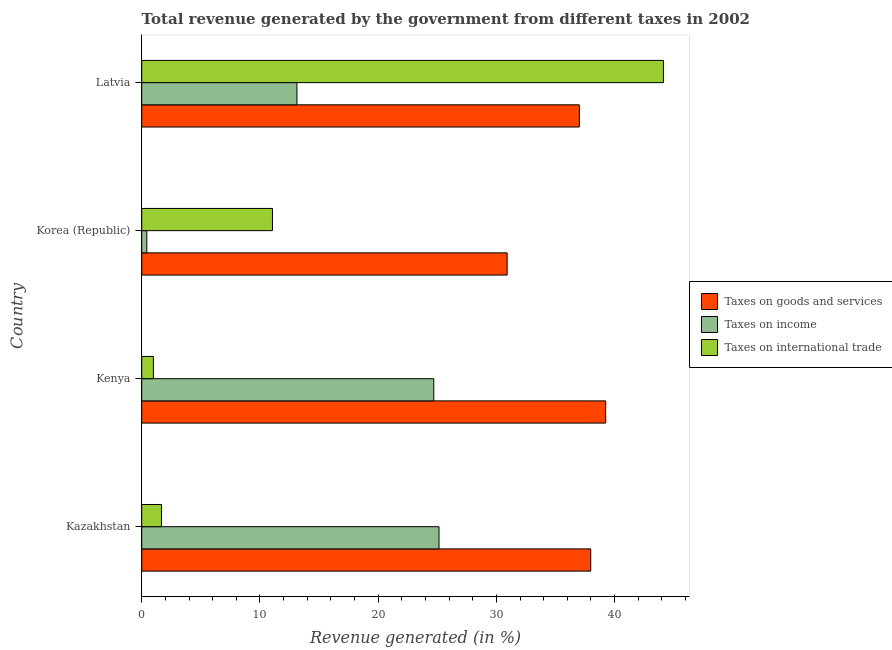How many different coloured bars are there?
Your response must be concise. 3. How many groups of bars are there?
Offer a terse response. 4. Are the number of bars on each tick of the Y-axis equal?
Your response must be concise. Yes. What is the label of the 3rd group of bars from the top?
Provide a short and direct response. Kenya. In how many cases, is the number of bars for a given country not equal to the number of legend labels?
Your answer should be very brief. 0. What is the percentage of revenue generated by taxes on goods and services in Kazakhstan?
Keep it short and to the point. 37.98. Across all countries, what is the maximum percentage of revenue generated by taxes on goods and services?
Your response must be concise. 39.24. Across all countries, what is the minimum percentage of revenue generated by taxes on income?
Provide a succinct answer. 0.43. In which country was the percentage of revenue generated by tax on international trade maximum?
Your response must be concise. Latvia. In which country was the percentage of revenue generated by taxes on income minimum?
Ensure brevity in your answer.  Korea (Republic). What is the total percentage of revenue generated by taxes on income in the graph?
Your answer should be compact. 63.41. What is the difference between the percentage of revenue generated by tax on international trade in Korea (Republic) and that in Latvia?
Your response must be concise. -33.07. What is the difference between the percentage of revenue generated by tax on international trade in Latvia and the percentage of revenue generated by taxes on goods and services in Kenya?
Give a very brief answer. 4.89. What is the average percentage of revenue generated by taxes on goods and services per country?
Provide a short and direct response. 36.29. What is the difference between the percentage of revenue generated by taxes on goods and services and percentage of revenue generated by tax on international trade in Kenya?
Ensure brevity in your answer.  38.26. What is the ratio of the percentage of revenue generated by taxes on income in Kazakhstan to that in Korea (Republic)?
Keep it short and to the point. 58.42. What is the difference between the highest and the second highest percentage of revenue generated by taxes on income?
Give a very brief answer. 0.44. What is the difference between the highest and the lowest percentage of revenue generated by taxes on goods and services?
Make the answer very short. 8.33. Is the sum of the percentage of revenue generated by taxes on income in Kazakhstan and Korea (Republic) greater than the maximum percentage of revenue generated by taxes on goods and services across all countries?
Provide a short and direct response. No. What does the 2nd bar from the top in Latvia represents?
Your answer should be very brief. Taxes on income. What does the 2nd bar from the bottom in Kenya represents?
Your response must be concise. Taxes on income. How many bars are there?
Your answer should be very brief. 12. Are all the bars in the graph horizontal?
Provide a succinct answer. Yes. What is the difference between two consecutive major ticks on the X-axis?
Give a very brief answer. 10. Does the graph contain any zero values?
Keep it short and to the point. No. Where does the legend appear in the graph?
Offer a terse response. Center right. How many legend labels are there?
Your answer should be compact. 3. What is the title of the graph?
Offer a very short reply. Total revenue generated by the government from different taxes in 2002. What is the label or title of the X-axis?
Your response must be concise. Revenue generated (in %). What is the Revenue generated (in %) in Taxes on goods and services in Kazakhstan?
Make the answer very short. 37.98. What is the Revenue generated (in %) of Taxes on income in Kazakhstan?
Your answer should be compact. 25.15. What is the Revenue generated (in %) of Taxes on international trade in Kazakhstan?
Make the answer very short. 1.67. What is the Revenue generated (in %) in Taxes on goods and services in Kenya?
Offer a terse response. 39.24. What is the Revenue generated (in %) of Taxes on income in Kenya?
Your response must be concise. 24.71. What is the Revenue generated (in %) in Taxes on international trade in Kenya?
Offer a very short reply. 0.99. What is the Revenue generated (in %) in Taxes on goods and services in Korea (Republic)?
Make the answer very short. 30.91. What is the Revenue generated (in %) in Taxes on income in Korea (Republic)?
Make the answer very short. 0.43. What is the Revenue generated (in %) in Taxes on international trade in Korea (Republic)?
Offer a very short reply. 11.06. What is the Revenue generated (in %) in Taxes on goods and services in Latvia?
Ensure brevity in your answer.  37.02. What is the Revenue generated (in %) in Taxes on income in Latvia?
Offer a very short reply. 13.13. What is the Revenue generated (in %) of Taxes on international trade in Latvia?
Provide a short and direct response. 44.13. Across all countries, what is the maximum Revenue generated (in %) of Taxes on goods and services?
Ensure brevity in your answer.  39.24. Across all countries, what is the maximum Revenue generated (in %) of Taxes on income?
Provide a short and direct response. 25.15. Across all countries, what is the maximum Revenue generated (in %) of Taxes on international trade?
Offer a terse response. 44.13. Across all countries, what is the minimum Revenue generated (in %) in Taxes on goods and services?
Provide a short and direct response. 30.91. Across all countries, what is the minimum Revenue generated (in %) in Taxes on income?
Give a very brief answer. 0.43. Across all countries, what is the minimum Revenue generated (in %) of Taxes on international trade?
Your answer should be very brief. 0.99. What is the total Revenue generated (in %) of Taxes on goods and services in the graph?
Offer a very short reply. 145.15. What is the total Revenue generated (in %) of Taxes on income in the graph?
Keep it short and to the point. 63.41. What is the total Revenue generated (in %) of Taxes on international trade in the graph?
Your answer should be very brief. 57.85. What is the difference between the Revenue generated (in %) of Taxes on goods and services in Kazakhstan and that in Kenya?
Make the answer very short. -1.26. What is the difference between the Revenue generated (in %) of Taxes on income in Kazakhstan and that in Kenya?
Your answer should be very brief. 0.44. What is the difference between the Revenue generated (in %) in Taxes on international trade in Kazakhstan and that in Kenya?
Offer a terse response. 0.69. What is the difference between the Revenue generated (in %) in Taxes on goods and services in Kazakhstan and that in Korea (Republic)?
Give a very brief answer. 7.07. What is the difference between the Revenue generated (in %) in Taxes on income in Kazakhstan and that in Korea (Republic)?
Offer a terse response. 24.72. What is the difference between the Revenue generated (in %) of Taxes on international trade in Kazakhstan and that in Korea (Republic)?
Give a very brief answer. -9.39. What is the difference between the Revenue generated (in %) in Taxes on goods and services in Kazakhstan and that in Latvia?
Your answer should be very brief. 0.96. What is the difference between the Revenue generated (in %) in Taxes on income in Kazakhstan and that in Latvia?
Your answer should be compact. 12.02. What is the difference between the Revenue generated (in %) in Taxes on international trade in Kazakhstan and that in Latvia?
Ensure brevity in your answer.  -42.46. What is the difference between the Revenue generated (in %) in Taxes on goods and services in Kenya and that in Korea (Republic)?
Ensure brevity in your answer.  8.33. What is the difference between the Revenue generated (in %) of Taxes on income in Kenya and that in Korea (Republic)?
Your answer should be compact. 24.28. What is the difference between the Revenue generated (in %) of Taxes on international trade in Kenya and that in Korea (Republic)?
Make the answer very short. -10.07. What is the difference between the Revenue generated (in %) of Taxes on goods and services in Kenya and that in Latvia?
Offer a very short reply. 2.23. What is the difference between the Revenue generated (in %) of Taxes on income in Kenya and that in Latvia?
Your answer should be very brief. 11.58. What is the difference between the Revenue generated (in %) of Taxes on international trade in Kenya and that in Latvia?
Ensure brevity in your answer.  -43.14. What is the difference between the Revenue generated (in %) in Taxes on goods and services in Korea (Republic) and that in Latvia?
Your answer should be very brief. -6.11. What is the difference between the Revenue generated (in %) in Taxes on income in Korea (Republic) and that in Latvia?
Ensure brevity in your answer.  -12.7. What is the difference between the Revenue generated (in %) of Taxes on international trade in Korea (Republic) and that in Latvia?
Your response must be concise. -33.07. What is the difference between the Revenue generated (in %) of Taxes on goods and services in Kazakhstan and the Revenue generated (in %) of Taxes on income in Kenya?
Your answer should be compact. 13.28. What is the difference between the Revenue generated (in %) of Taxes on goods and services in Kazakhstan and the Revenue generated (in %) of Taxes on international trade in Kenya?
Your answer should be very brief. 36.99. What is the difference between the Revenue generated (in %) of Taxes on income in Kazakhstan and the Revenue generated (in %) of Taxes on international trade in Kenya?
Your answer should be very brief. 24.16. What is the difference between the Revenue generated (in %) in Taxes on goods and services in Kazakhstan and the Revenue generated (in %) in Taxes on income in Korea (Republic)?
Offer a terse response. 37.55. What is the difference between the Revenue generated (in %) in Taxes on goods and services in Kazakhstan and the Revenue generated (in %) in Taxes on international trade in Korea (Republic)?
Ensure brevity in your answer.  26.92. What is the difference between the Revenue generated (in %) of Taxes on income in Kazakhstan and the Revenue generated (in %) of Taxes on international trade in Korea (Republic)?
Provide a short and direct response. 14.09. What is the difference between the Revenue generated (in %) in Taxes on goods and services in Kazakhstan and the Revenue generated (in %) in Taxes on income in Latvia?
Your answer should be very brief. 24.85. What is the difference between the Revenue generated (in %) in Taxes on goods and services in Kazakhstan and the Revenue generated (in %) in Taxes on international trade in Latvia?
Your answer should be compact. -6.15. What is the difference between the Revenue generated (in %) in Taxes on income in Kazakhstan and the Revenue generated (in %) in Taxes on international trade in Latvia?
Offer a very short reply. -18.98. What is the difference between the Revenue generated (in %) in Taxes on goods and services in Kenya and the Revenue generated (in %) in Taxes on income in Korea (Republic)?
Give a very brief answer. 38.81. What is the difference between the Revenue generated (in %) of Taxes on goods and services in Kenya and the Revenue generated (in %) of Taxes on international trade in Korea (Republic)?
Your answer should be compact. 28.18. What is the difference between the Revenue generated (in %) in Taxes on income in Kenya and the Revenue generated (in %) in Taxes on international trade in Korea (Republic)?
Your answer should be very brief. 13.65. What is the difference between the Revenue generated (in %) in Taxes on goods and services in Kenya and the Revenue generated (in %) in Taxes on income in Latvia?
Provide a short and direct response. 26.11. What is the difference between the Revenue generated (in %) in Taxes on goods and services in Kenya and the Revenue generated (in %) in Taxes on international trade in Latvia?
Your response must be concise. -4.89. What is the difference between the Revenue generated (in %) of Taxes on income in Kenya and the Revenue generated (in %) of Taxes on international trade in Latvia?
Your answer should be very brief. -19.43. What is the difference between the Revenue generated (in %) in Taxes on goods and services in Korea (Republic) and the Revenue generated (in %) in Taxes on income in Latvia?
Your answer should be very brief. 17.78. What is the difference between the Revenue generated (in %) in Taxes on goods and services in Korea (Republic) and the Revenue generated (in %) in Taxes on international trade in Latvia?
Provide a short and direct response. -13.22. What is the difference between the Revenue generated (in %) in Taxes on income in Korea (Republic) and the Revenue generated (in %) in Taxes on international trade in Latvia?
Provide a short and direct response. -43.7. What is the average Revenue generated (in %) in Taxes on goods and services per country?
Your response must be concise. 36.29. What is the average Revenue generated (in %) of Taxes on income per country?
Your answer should be compact. 15.85. What is the average Revenue generated (in %) of Taxes on international trade per country?
Your response must be concise. 14.46. What is the difference between the Revenue generated (in %) in Taxes on goods and services and Revenue generated (in %) in Taxes on income in Kazakhstan?
Provide a succinct answer. 12.83. What is the difference between the Revenue generated (in %) in Taxes on goods and services and Revenue generated (in %) in Taxes on international trade in Kazakhstan?
Ensure brevity in your answer.  36.31. What is the difference between the Revenue generated (in %) in Taxes on income and Revenue generated (in %) in Taxes on international trade in Kazakhstan?
Give a very brief answer. 23.48. What is the difference between the Revenue generated (in %) of Taxes on goods and services and Revenue generated (in %) of Taxes on income in Kenya?
Provide a succinct answer. 14.54. What is the difference between the Revenue generated (in %) of Taxes on goods and services and Revenue generated (in %) of Taxes on international trade in Kenya?
Provide a succinct answer. 38.26. What is the difference between the Revenue generated (in %) of Taxes on income and Revenue generated (in %) of Taxes on international trade in Kenya?
Ensure brevity in your answer.  23.72. What is the difference between the Revenue generated (in %) of Taxes on goods and services and Revenue generated (in %) of Taxes on income in Korea (Republic)?
Provide a short and direct response. 30.48. What is the difference between the Revenue generated (in %) in Taxes on goods and services and Revenue generated (in %) in Taxes on international trade in Korea (Republic)?
Offer a terse response. 19.85. What is the difference between the Revenue generated (in %) of Taxes on income and Revenue generated (in %) of Taxes on international trade in Korea (Republic)?
Offer a very short reply. -10.63. What is the difference between the Revenue generated (in %) of Taxes on goods and services and Revenue generated (in %) of Taxes on income in Latvia?
Your answer should be compact. 23.89. What is the difference between the Revenue generated (in %) of Taxes on goods and services and Revenue generated (in %) of Taxes on international trade in Latvia?
Your answer should be very brief. -7.11. What is the difference between the Revenue generated (in %) of Taxes on income and Revenue generated (in %) of Taxes on international trade in Latvia?
Give a very brief answer. -31. What is the ratio of the Revenue generated (in %) of Taxes on goods and services in Kazakhstan to that in Kenya?
Provide a succinct answer. 0.97. What is the ratio of the Revenue generated (in %) of Taxes on income in Kazakhstan to that in Kenya?
Your answer should be compact. 1.02. What is the ratio of the Revenue generated (in %) of Taxes on international trade in Kazakhstan to that in Kenya?
Your response must be concise. 1.69. What is the ratio of the Revenue generated (in %) of Taxes on goods and services in Kazakhstan to that in Korea (Republic)?
Keep it short and to the point. 1.23. What is the ratio of the Revenue generated (in %) in Taxes on income in Kazakhstan to that in Korea (Republic)?
Offer a terse response. 58.42. What is the ratio of the Revenue generated (in %) in Taxes on international trade in Kazakhstan to that in Korea (Republic)?
Your answer should be compact. 0.15. What is the ratio of the Revenue generated (in %) in Taxes on goods and services in Kazakhstan to that in Latvia?
Make the answer very short. 1.03. What is the ratio of the Revenue generated (in %) of Taxes on income in Kazakhstan to that in Latvia?
Provide a succinct answer. 1.92. What is the ratio of the Revenue generated (in %) of Taxes on international trade in Kazakhstan to that in Latvia?
Make the answer very short. 0.04. What is the ratio of the Revenue generated (in %) in Taxes on goods and services in Kenya to that in Korea (Republic)?
Give a very brief answer. 1.27. What is the ratio of the Revenue generated (in %) in Taxes on income in Kenya to that in Korea (Republic)?
Provide a short and direct response. 57.39. What is the ratio of the Revenue generated (in %) in Taxes on international trade in Kenya to that in Korea (Republic)?
Offer a terse response. 0.09. What is the ratio of the Revenue generated (in %) of Taxes on goods and services in Kenya to that in Latvia?
Provide a succinct answer. 1.06. What is the ratio of the Revenue generated (in %) of Taxes on income in Kenya to that in Latvia?
Ensure brevity in your answer.  1.88. What is the ratio of the Revenue generated (in %) in Taxes on international trade in Kenya to that in Latvia?
Provide a short and direct response. 0.02. What is the ratio of the Revenue generated (in %) of Taxes on goods and services in Korea (Republic) to that in Latvia?
Provide a succinct answer. 0.83. What is the ratio of the Revenue generated (in %) of Taxes on income in Korea (Republic) to that in Latvia?
Your answer should be compact. 0.03. What is the ratio of the Revenue generated (in %) in Taxes on international trade in Korea (Republic) to that in Latvia?
Offer a very short reply. 0.25. What is the difference between the highest and the second highest Revenue generated (in %) in Taxes on goods and services?
Your response must be concise. 1.26. What is the difference between the highest and the second highest Revenue generated (in %) in Taxes on income?
Make the answer very short. 0.44. What is the difference between the highest and the second highest Revenue generated (in %) of Taxes on international trade?
Keep it short and to the point. 33.07. What is the difference between the highest and the lowest Revenue generated (in %) of Taxes on goods and services?
Ensure brevity in your answer.  8.33. What is the difference between the highest and the lowest Revenue generated (in %) in Taxes on income?
Offer a terse response. 24.72. What is the difference between the highest and the lowest Revenue generated (in %) of Taxes on international trade?
Ensure brevity in your answer.  43.14. 